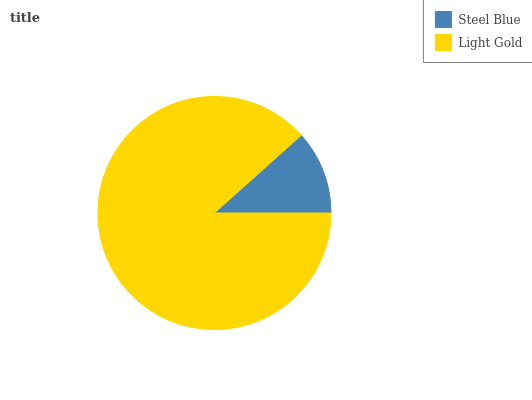Is Steel Blue the minimum?
Answer yes or no. Yes. Is Light Gold the maximum?
Answer yes or no. Yes. Is Light Gold the minimum?
Answer yes or no. No. Is Light Gold greater than Steel Blue?
Answer yes or no. Yes. Is Steel Blue less than Light Gold?
Answer yes or no. Yes. Is Steel Blue greater than Light Gold?
Answer yes or no. No. Is Light Gold less than Steel Blue?
Answer yes or no. No. Is Light Gold the high median?
Answer yes or no. Yes. Is Steel Blue the low median?
Answer yes or no. Yes. Is Steel Blue the high median?
Answer yes or no. No. Is Light Gold the low median?
Answer yes or no. No. 